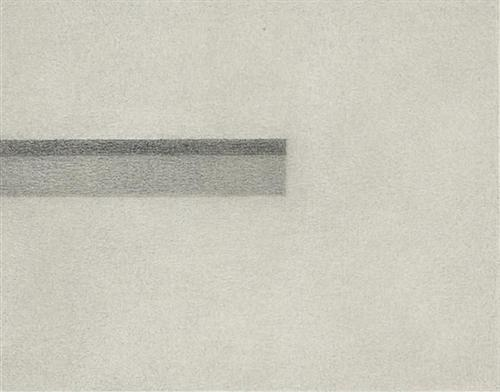What feeling does this image convey? The image’s use of simple, unembellished forms combined with a stark monochromatic scheme conveys a feeling of serenity and calmness. The uninterrupted line suggests continuity and steadiness, potentially evoking a sensation of introspective tranquility in the viewer. 